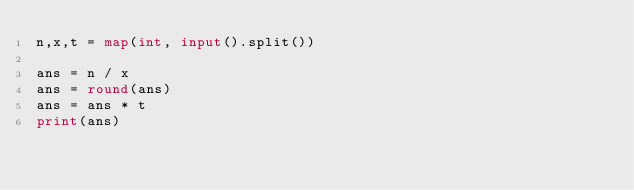<code> <loc_0><loc_0><loc_500><loc_500><_Python_>n,x,t = map(int, input().split())

ans = n / x
ans = round(ans)
ans = ans * t
print(ans)</code> 